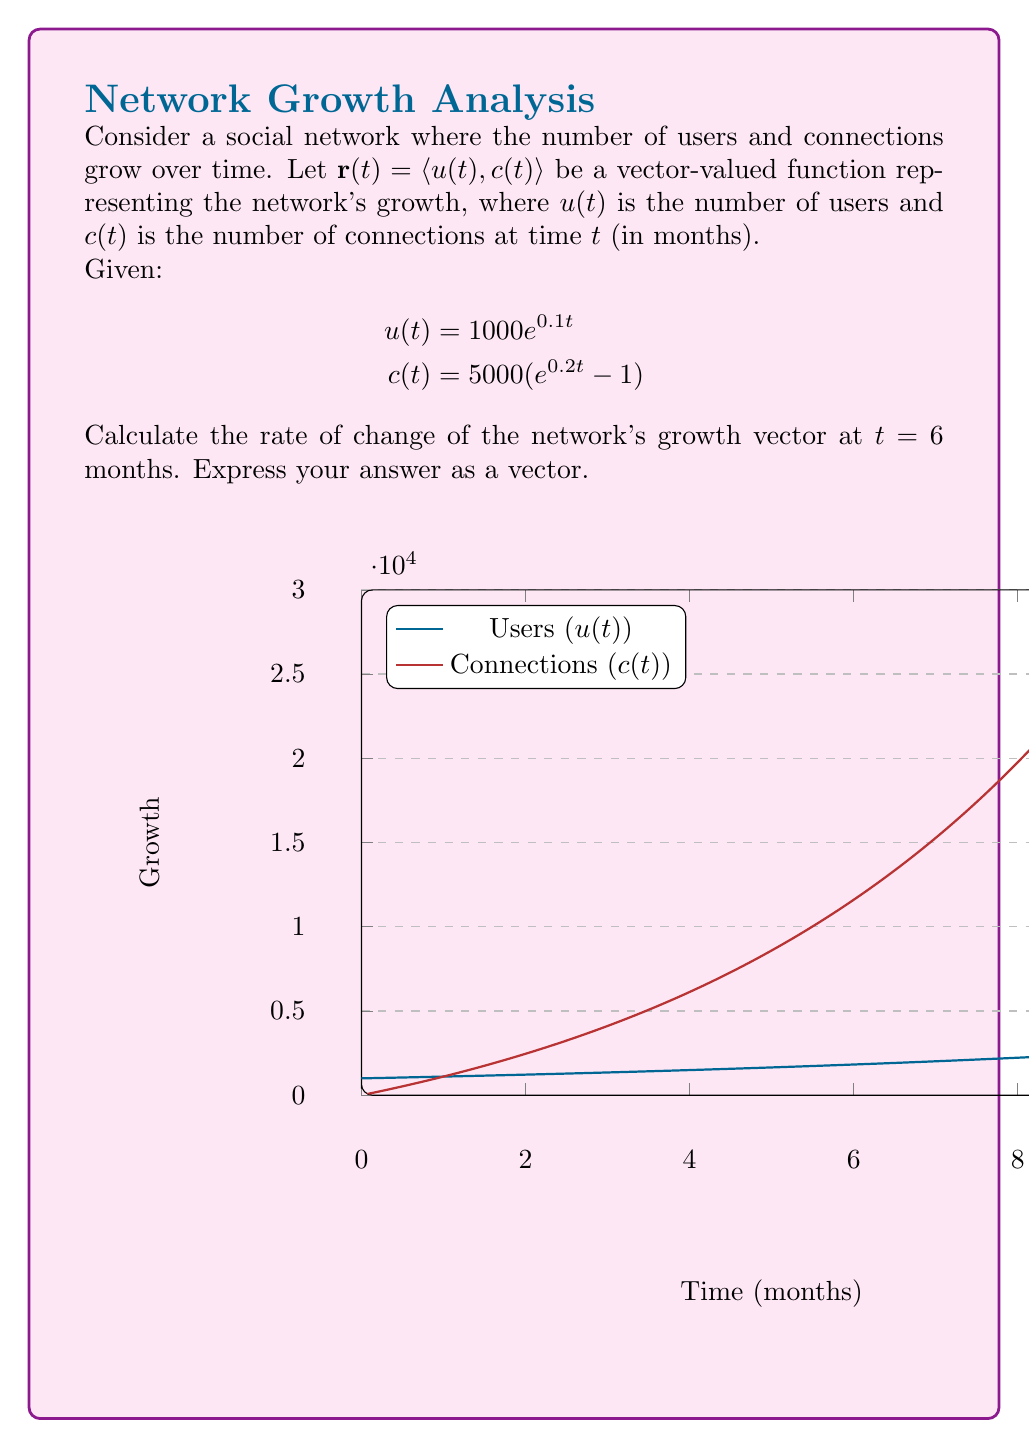Can you answer this question? To find the rate of change of the network's growth vector at $t = 6$ months, we need to calculate the derivative of $\mathbf{r}(t)$ and evaluate it at $t = 6$.

Step 1: Find $\mathbf{r}'(t)$
The derivative of a vector-valued function is the vector of the derivatives of its components:

$$\mathbf{r}'(t) = \langle u'(t), c'(t) \rangle$$

Step 2: Calculate $u'(t)$
$$u'(t) = \frac{d}{dt}(1000e^{0.1t}) = 1000 \cdot 0.1e^{0.1t} = 100e^{0.1t}$$

Step 3: Calculate $c'(t)$
$$c'(t) = \frac{d}{dt}(5000(e^{0.2t} - 1)) = 5000 \cdot 0.2e^{0.2t} = 1000e^{0.2t}$$

Step 4: Express $\mathbf{r}'(t)$
$$\mathbf{r}'(t) = \langle 100e^{0.1t}, 1000e^{0.2t} \rangle$$

Step 5: Evaluate $\mathbf{r}'(t)$ at $t = 6$
$$\mathbf{r}'(6) = \langle 100e^{0.1(6)}, 1000e^{0.2(6)} \rangle$$
$$= \langle 100e^{0.6}, 1000e^{1.2} \rangle$$
$$\approx \langle 182.21, 3320.12 \rangle$$

This vector represents the instantaneous rate of change in the number of users (approximately 182 users per month) and connections (approximately 3320 connections per month) at $t = 6$ months.
Answer: $\langle 100e^{0.6}, 1000e^{1.2} \rangle$ or $\langle 182.21, 3320.12 \rangle$ 